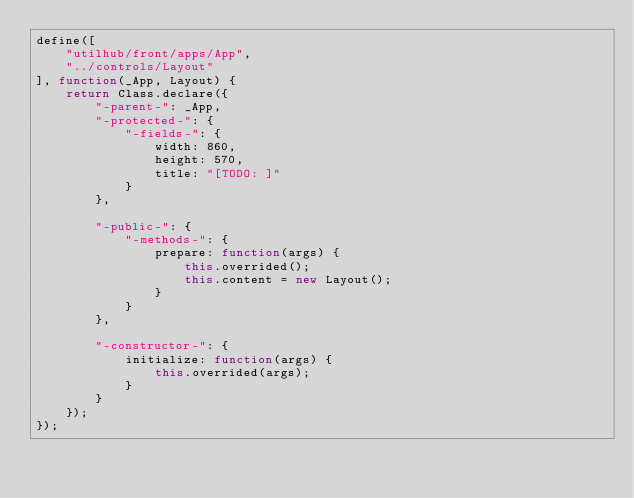Convert code to text. <code><loc_0><loc_0><loc_500><loc_500><_JavaScript_>define([
    "utilhub/front/apps/App",
    "../controls/Layout"
], function(_App, Layout) {
    return Class.declare({
        "-parent-": _App,
        "-protected-": {
            "-fields-": {
                width: 860,
                height: 570,
                title: "[TODO: ]"
            }
        },

        "-public-": {
            "-methods-": {
                prepare: function(args) {
                    this.overrided();
                    this.content = new Layout();
                }
            }
        },

        "-constructor-": {
            initialize: function(args) {
                this.overrided(args);
            }
        }
    });
});
</code> 